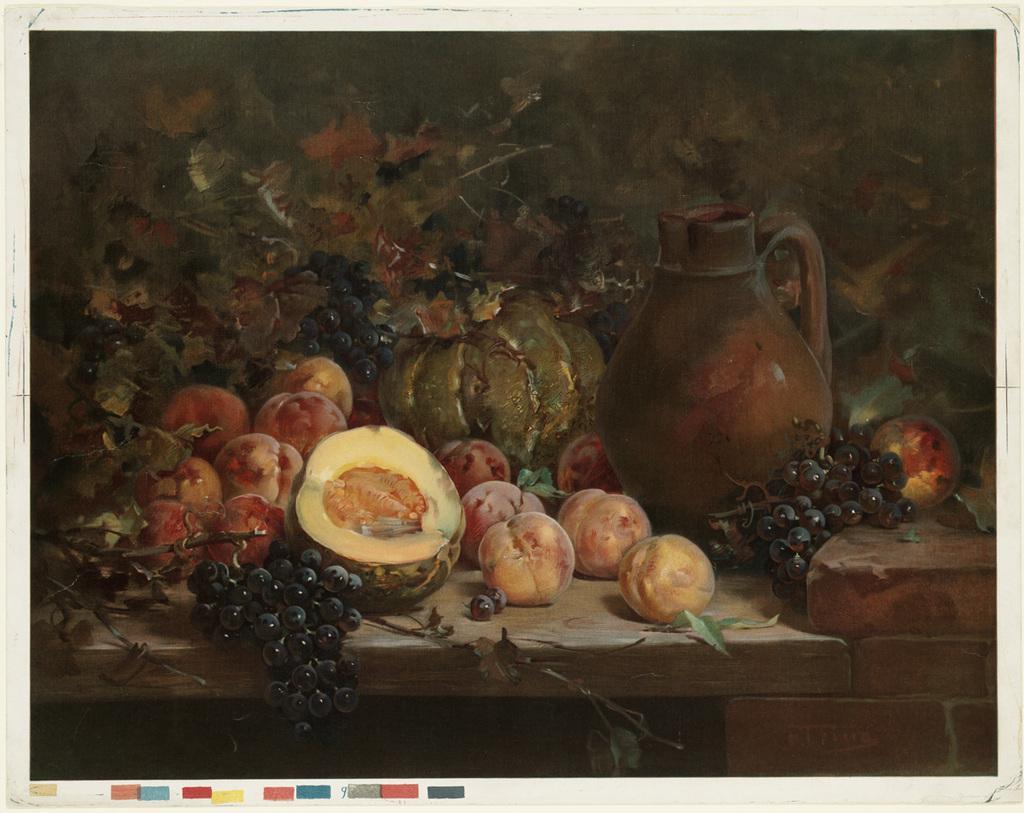Please provide a concise description of this image. Here we can see a painting. On this table there is a jug, grapes and fruits. 